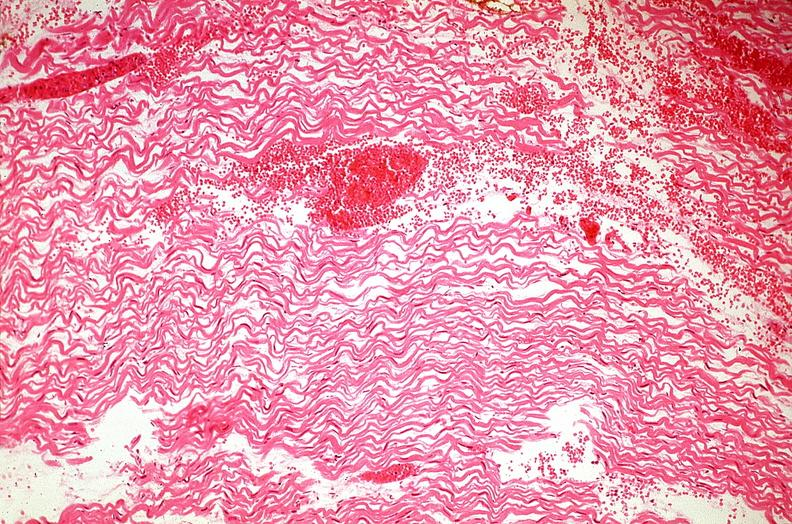what is present?
Answer the question using a single word or phrase. Cardiovascular 